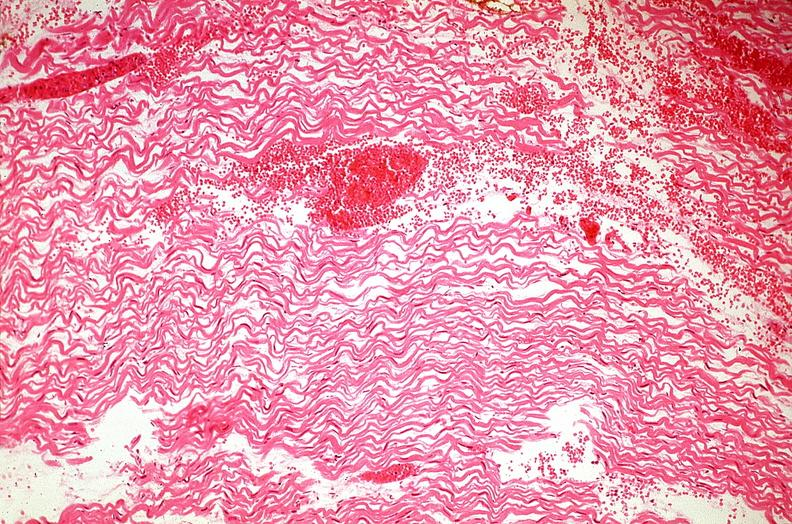what is present?
Answer the question using a single word or phrase. Cardiovascular 